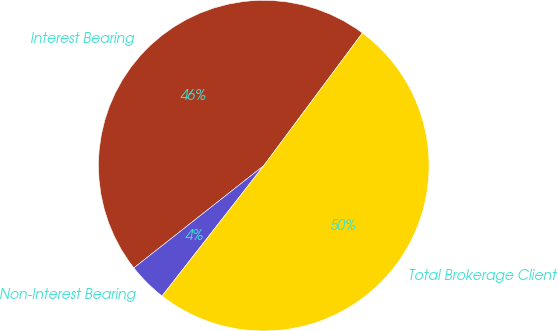Convert chart. <chart><loc_0><loc_0><loc_500><loc_500><pie_chart><fcel>Interest Bearing<fcel>Non-Interest Bearing<fcel>Total Brokerage Client<nl><fcel>45.79%<fcel>3.84%<fcel>50.37%<nl></chart> 